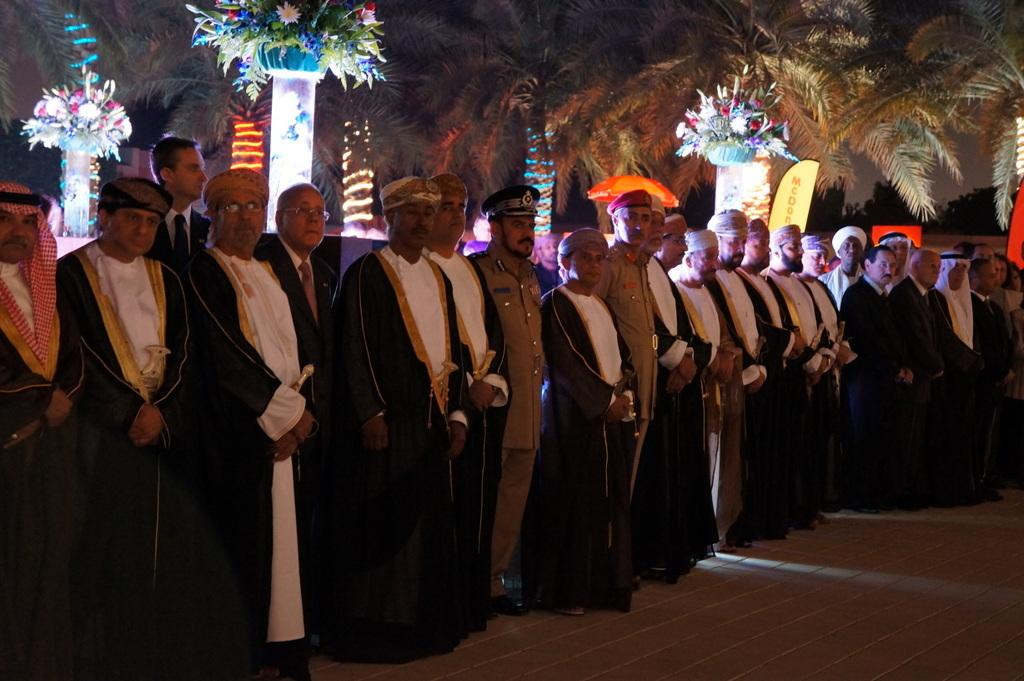What can be seen in the image? There are people standing in the image. Can you describe the clothing of the people? The people are wearing different color dresses. What is visible in the background of the image? There are trees, colorful flowers, lights, and an orange umbrella in the background of the image. What type of lipstick is the pet wearing in the image? There is no pet present in the image, and therefore no lipstick or pet can be observed. 